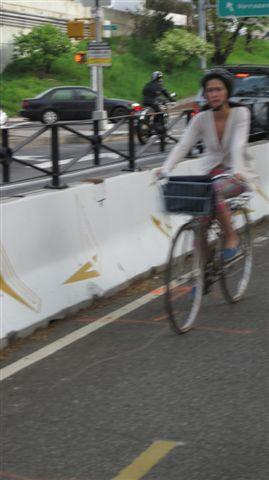How is the women moving? Please explain your reasoning. bicycling. The woman is moving down the street on a bicycle. 